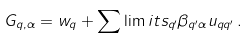<formula> <loc_0><loc_0><loc_500><loc_500>G _ { q , \alpha } = w _ { q } + \sum \lim i t s _ { q ^ { \prime } } { \beta _ { q ^ { \prime } \alpha } u _ { q q ^ { \prime } } } \, .</formula> 